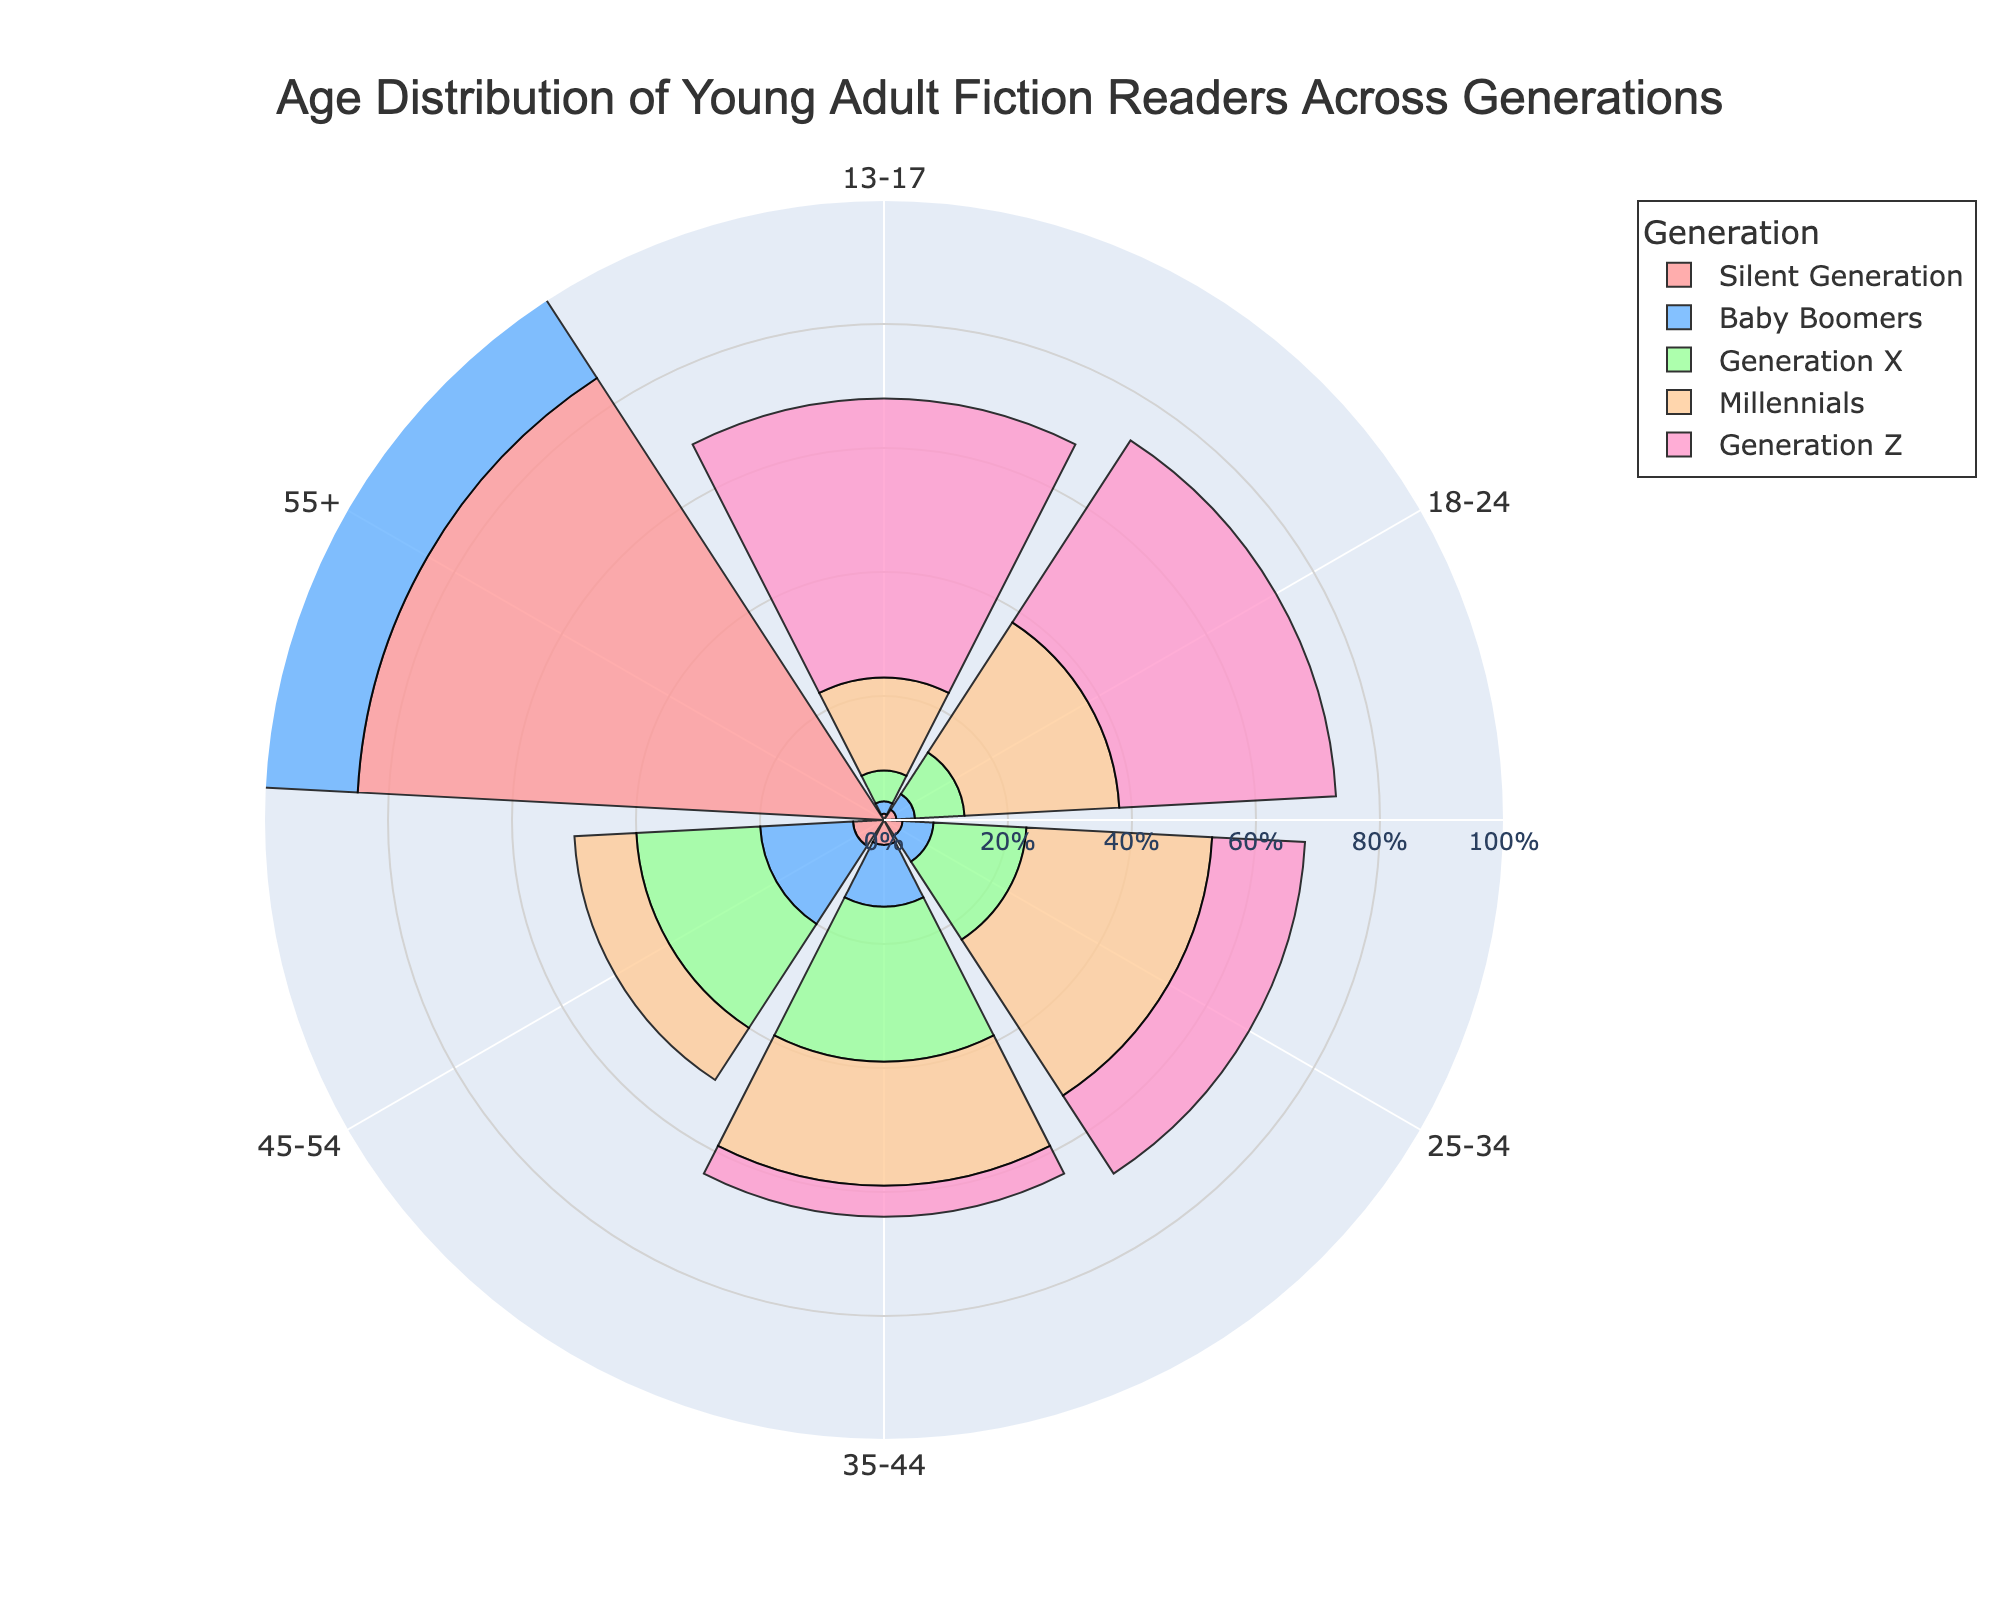What is the title of the figure? The title of the figure is usually found at the top of the chart. In this case, it states the main subject of the chart.
Answer: Age Distribution of Young Adult Fiction Readers Across Generations Which generation has the highest percentage of readers in the age group 13-17? To find this, look at the barpolar segments for each generation corresponding to the 13-17 age group. Identify which segment extends furthest from the center.
Answer: Generation Z How does the percentage of readers in the 18-24 age group compare between Millennials and Baby Boomers? Compare the lengths of the barpolar segments for Millennials and Baby Boomers in the 18-24 age group.
Answer: Millennials have a higher percentage What is the combined percentage of readers aged 55+ for the Silent Generation and Baby Boomers? Add the percentage values for the Silent Generation and Baby Boomers in the 55+ age group.
Answer: 150% Which generation shows the greatest variety in age distribution percentages? Check the range of percentages within each generation and identify which varies the most from the smallest to largest values.
Answer: Silent Generation What is the percentage difference between Generation X and Generation Z in the 25-34 age group? Subtract the percentage of Generation Z readers in the 25-34 age group from that of Generation X.
Answer: 15% Which age group has the highest percentage of readers not from the Silent Generation? Exclude the Silent Generation, then look for the age group with the highest percentage amongst the remaining generations.
Answer: 13-17 How do the percentages of readers aged 35-44 compare among Generation X and Millennials? Compare the lengths of the barpolar segments for Generation X and Millennials in the 35-44 age group.
Answer: Generation X has a higher percentage In which age groups does Generation Z have no readers? Identify the barpolar segments for Generation Z that are non-existent or have a value of zero.
Answer: 45-54, 55+ What is the difference in reader percentages between Baby Boomers and Generation X in the 45-54 age group? Subtract the percentage of Generation X readers from the percentage of Baby Boomers in the 45-54 age group.
Answer: 5% 